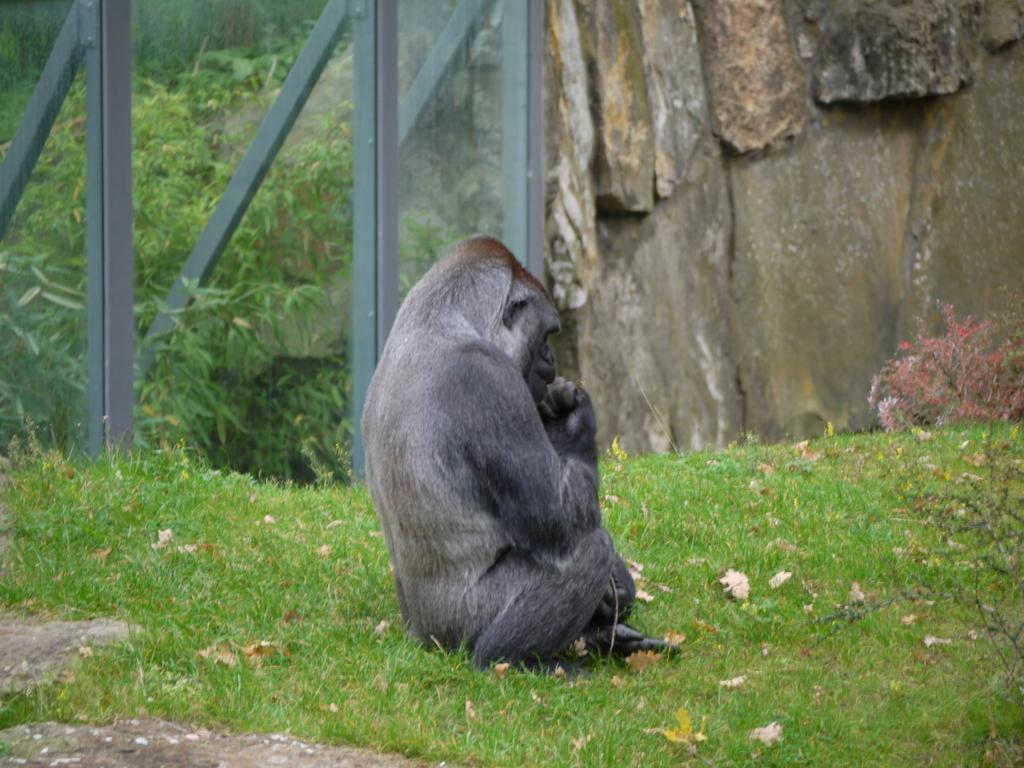What animal is the main subject of the image? There is a gorilla in the image. What is the gorilla sitting on? The gorilla is sitting on grass. What type of vegetation can be seen in the image? Trees are present in the image. What objects can be seen in the image besides the gorilla? There are rods and a wall visible in the image. What historical event is being commemorated by the crowd in the image? There is no crowd present in the image, and therefore no historical event can be observed. What type of rifle is the gorilla holding in the image? There is no rifle present in the image; the gorilla is simply sitting on the grass. 